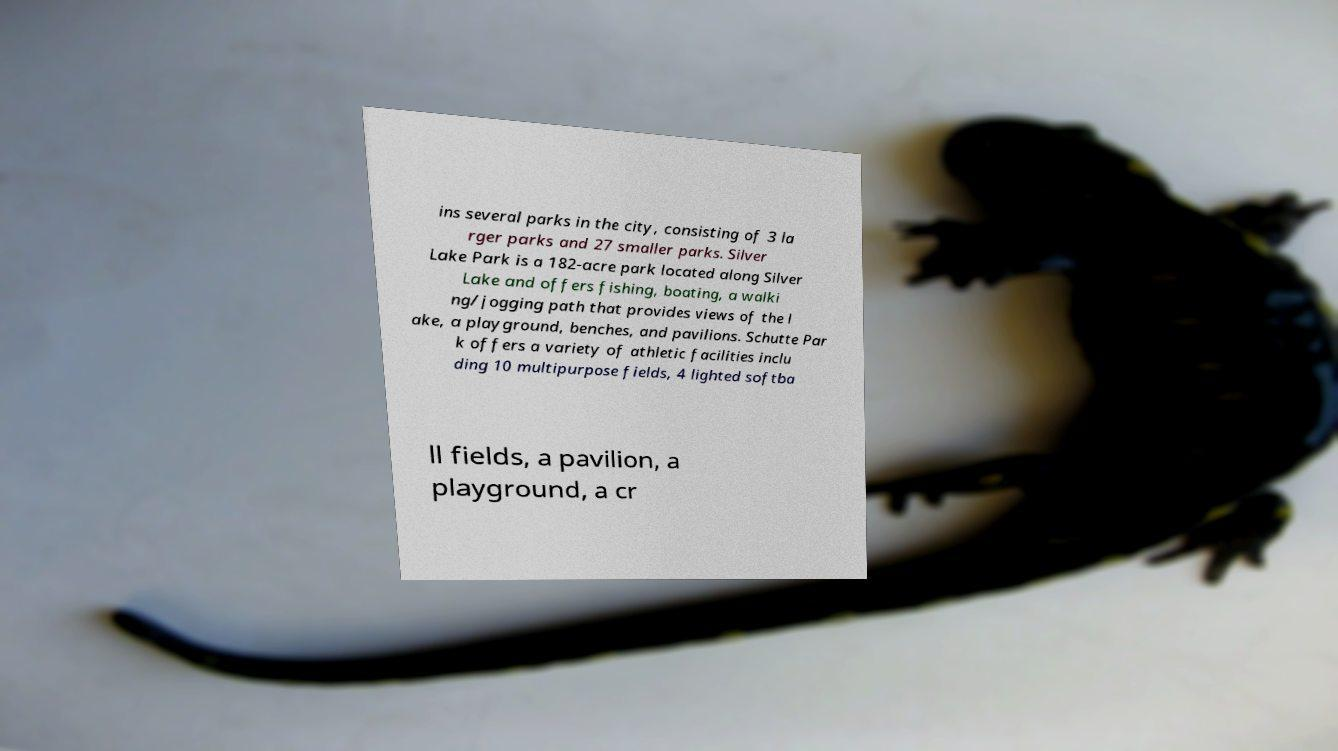Can you read and provide the text displayed in the image?This photo seems to have some interesting text. Can you extract and type it out for me? ins several parks in the city, consisting of 3 la rger parks and 27 smaller parks. Silver Lake Park is a 182-acre park located along Silver Lake and offers fishing, boating, a walki ng/jogging path that provides views of the l ake, a playground, benches, and pavilions. Schutte Par k offers a variety of athletic facilities inclu ding 10 multipurpose fields, 4 lighted softba ll fields, a pavilion, a playground, a cr 